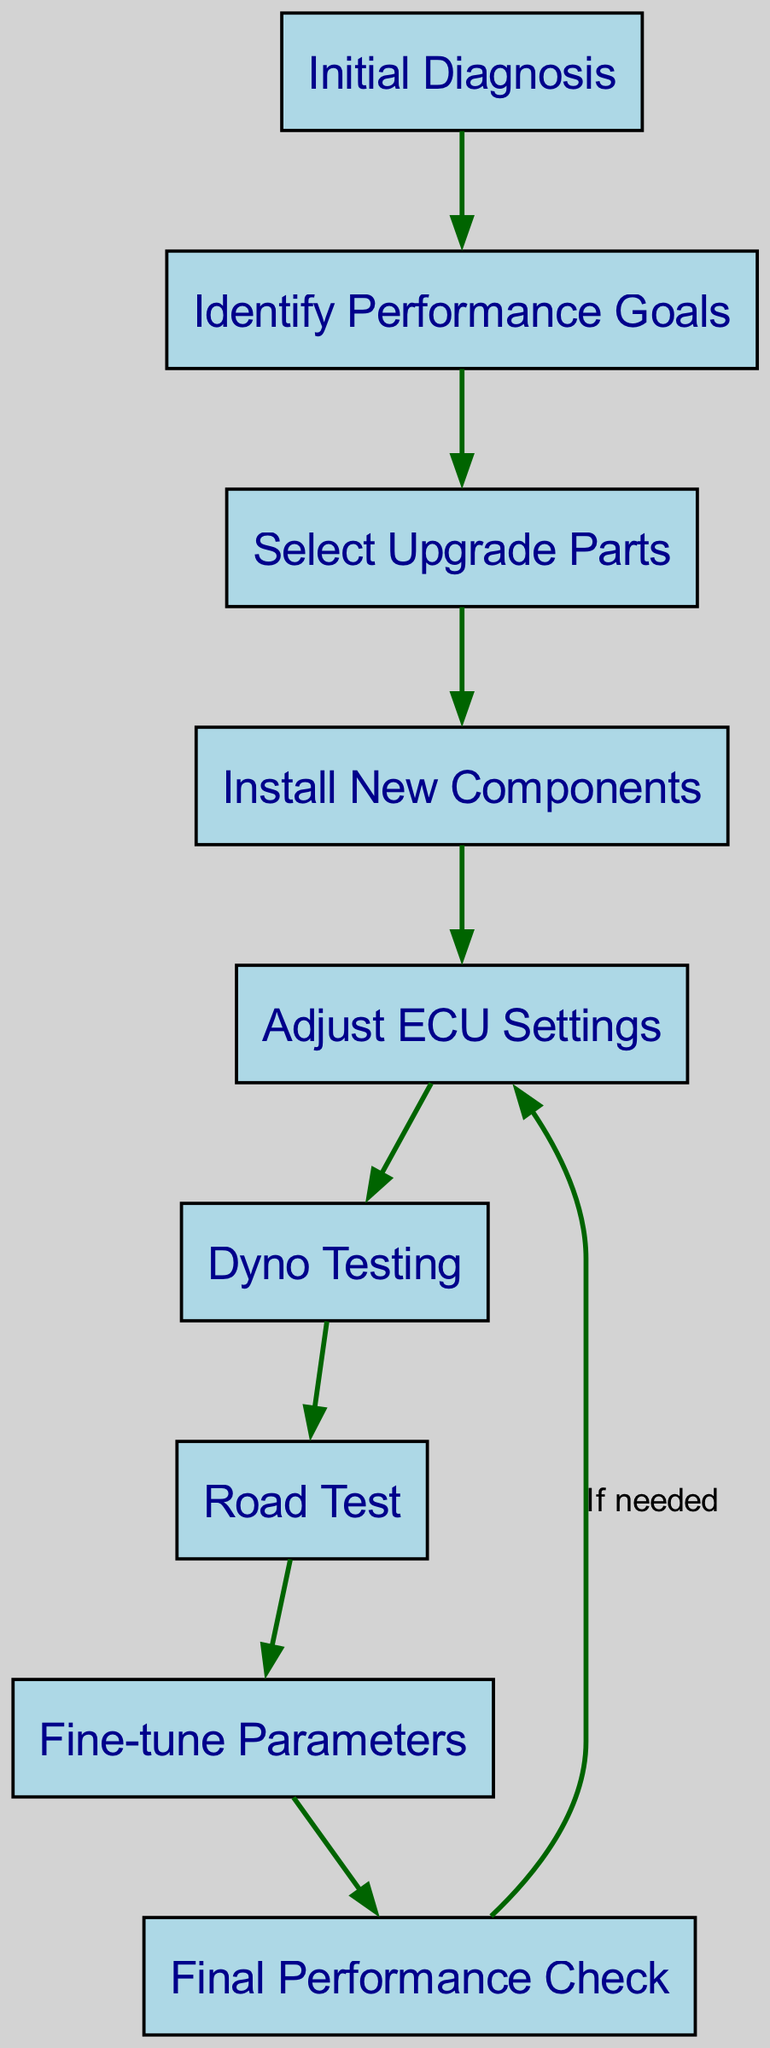What is the first step in the engine tuning process? The diagram shows "Initial Diagnosis" as the first node that initiates the process.
Answer: Initial Diagnosis How many nodes are present in the diagram? By counting the distinct nodes listed in the data, there are a total of nine nodes in the diagram.
Answer: 9 What is the relationship between "Adjust ECU Settings" and "Dyno Testing"? "Adjust ECU Settings" directly leads to "Dyno Testing", indicating a sequential process where adjustments are made before testing.
Answer: Directly leads to What step follows "Fine-tune Parameters"? According to the flowchart, the step that follows "Fine-tune Parameters" is "Final Performance Check".
Answer: Final Performance Check What occurs if the "Final Performance Check" needs adjustments? If the "Final Performance Check" indicates the need for adjustments, it loops back to "Adjust ECU Settings", showing a feedback mechanism in the process.
Answer: Adjust ECU Settings How many edges connect the nodes in this diagram? By analyzing the edges described, there are eight directed edges connecting the nodes in the graph.
Answer: 8 What is the last step in the engine tuning process? The last node in the directed graph is "Final Performance Check", which represents the concluding evaluation of the tuning process.
Answer: Final Performance Check What node comes immediately after "Road Test"? Looking at the progression in the diagram, the node that comes immediately after "Road Test" is "Fine-tune Parameters".
Answer: Fine-tune Parameters Which step requires testing the vehicle post-adjustments? The step that involves testing the vehicle after adjustments is "Road Test", following the theoretical ECU adjustments made earlier.
Answer: Road Test 